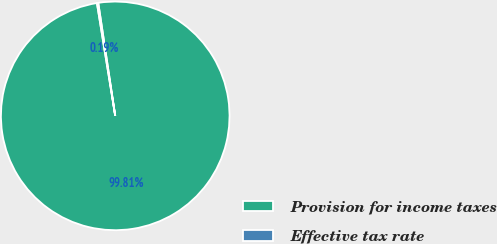<chart> <loc_0><loc_0><loc_500><loc_500><pie_chart><fcel>Provision for income taxes<fcel>Effective tax rate<nl><fcel>99.81%<fcel>0.19%<nl></chart> 